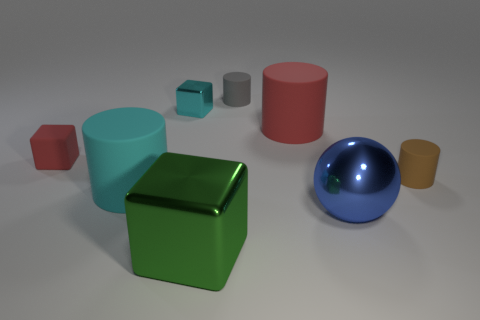Add 2 red things. How many objects exist? 10 Subtract all balls. How many objects are left? 7 Add 5 cyan shiny blocks. How many cyan shiny blocks are left? 6 Add 2 tiny cyan things. How many tiny cyan things exist? 3 Subtract 1 blue balls. How many objects are left? 7 Subtract all small metallic objects. Subtract all balls. How many objects are left? 6 